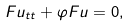<formula> <loc_0><loc_0><loc_500><loc_500>F u _ { t t } + \varphi F u = 0 ,</formula> 